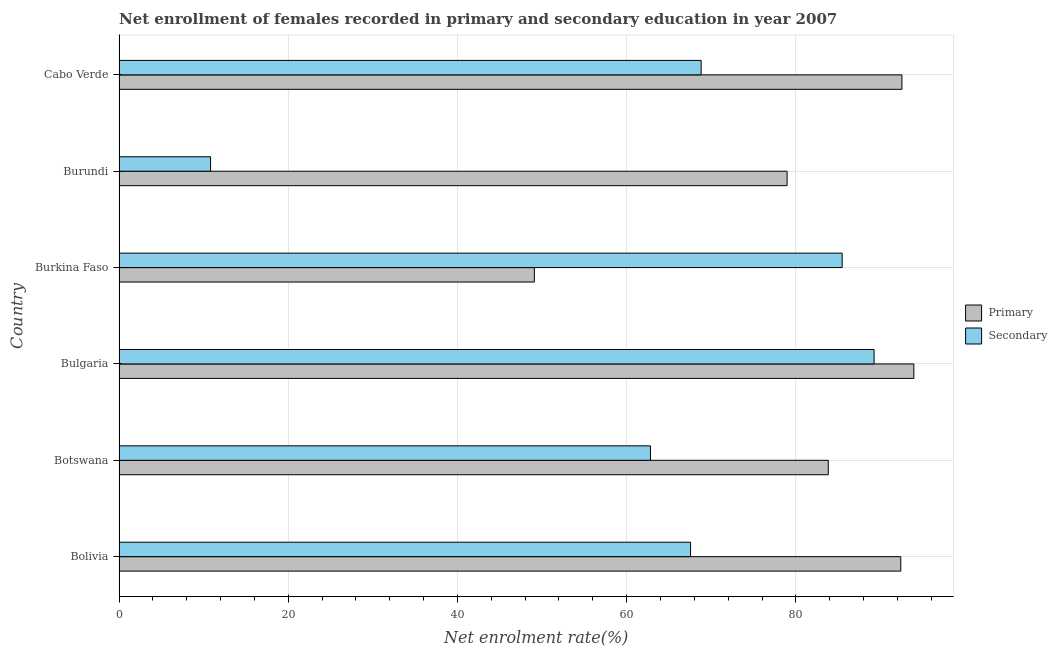How many groups of bars are there?
Your response must be concise. 6. Are the number of bars per tick equal to the number of legend labels?
Your answer should be very brief. Yes. Are the number of bars on each tick of the Y-axis equal?
Ensure brevity in your answer.  Yes. How many bars are there on the 4th tick from the top?
Your answer should be compact. 2. What is the label of the 3rd group of bars from the top?
Your response must be concise. Burkina Faso. In how many cases, is the number of bars for a given country not equal to the number of legend labels?
Your answer should be very brief. 0. What is the enrollment rate in primary education in Bolivia?
Provide a succinct answer. 92.4. Across all countries, what is the maximum enrollment rate in primary education?
Your answer should be very brief. 93.94. Across all countries, what is the minimum enrollment rate in secondary education?
Provide a short and direct response. 10.82. In which country was the enrollment rate in primary education maximum?
Make the answer very short. Bulgaria. In which country was the enrollment rate in primary education minimum?
Offer a terse response. Burkina Faso. What is the total enrollment rate in primary education in the graph?
Offer a terse response. 490.75. What is the difference between the enrollment rate in primary education in Burkina Faso and that in Burundi?
Offer a very short reply. -29.87. What is the difference between the enrollment rate in secondary education in Bulgaria and the enrollment rate in primary education in Burkina Faso?
Make the answer very short. 40.15. What is the average enrollment rate in primary education per country?
Your answer should be compact. 81.79. What is the difference between the enrollment rate in primary education and enrollment rate in secondary education in Bolivia?
Ensure brevity in your answer.  24.85. In how many countries, is the enrollment rate in primary education greater than 4 %?
Offer a very short reply. 6. What is the ratio of the enrollment rate in secondary education in Bolivia to that in Burkina Faso?
Keep it short and to the point. 0.79. Is the enrollment rate in primary education in Bolivia less than that in Bulgaria?
Ensure brevity in your answer.  Yes. What is the difference between the highest and the second highest enrollment rate in primary education?
Your answer should be compact. 1.41. What is the difference between the highest and the lowest enrollment rate in secondary education?
Keep it short and to the point. 78.42. In how many countries, is the enrollment rate in secondary education greater than the average enrollment rate in secondary education taken over all countries?
Your answer should be very brief. 4. Is the sum of the enrollment rate in secondary education in Bolivia and Botswana greater than the maximum enrollment rate in primary education across all countries?
Offer a terse response. Yes. What does the 1st bar from the top in Burkina Faso represents?
Offer a terse response. Secondary. What does the 1st bar from the bottom in Botswana represents?
Provide a succinct answer. Primary. How many bars are there?
Make the answer very short. 12. Are all the bars in the graph horizontal?
Ensure brevity in your answer.  Yes. Are the values on the major ticks of X-axis written in scientific E-notation?
Keep it short and to the point. No. Does the graph contain grids?
Your answer should be very brief. Yes. Where does the legend appear in the graph?
Give a very brief answer. Center right. What is the title of the graph?
Give a very brief answer. Net enrollment of females recorded in primary and secondary education in year 2007. What is the label or title of the X-axis?
Your response must be concise. Net enrolment rate(%). What is the label or title of the Y-axis?
Offer a very short reply. Country. What is the Net enrolment rate(%) in Primary in Bolivia?
Your answer should be very brief. 92.4. What is the Net enrolment rate(%) of Secondary in Bolivia?
Make the answer very short. 67.55. What is the Net enrolment rate(%) of Primary in Botswana?
Your response must be concise. 83.83. What is the Net enrolment rate(%) of Secondary in Botswana?
Provide a short and direct response. 62.81. What is the Net enrolment rate(%) of Primary in Bulgaria?
Offer a very short reply. 93.94. What is the Net enrolment rate(%) of Secondary in Bulgaria?
Provide a short and direct response. 89.24. What is the Net enrolment rate(%) of Primary in Burkina Faso?
Your answer should be compact. 49.09. What is the Net enrolment rate(%) of Secondary in Burkina Faso?
Give a very brief answer. 85.47. What is the Net enrolment rate(%) of Primary in Burundi?
Give a very brief answer. 78.96. What is the Net enrolment rate(%) in Secondary in Burundi?
Your response must be concise. 10.82. What is the Net enrolment rate(%) of Primary in Cabo Verde?
Provide a short and direct response. 92.53. What is the Net enrolment rate(%) of Secondary in Cabo Verde?
Your answer should be compact. 68.8. Across all countries, what is the maximum Net enrolment rate(%) in Primary?
Provide a succinct answer. 93.94. Across all countries, what is the maximum Net enrolment rate(%) in Secondary?
Provide a short and direct response. 89.24. Across all countries, what is the minimum Net enrolment rate(%) of Primary?
Keep it short and to the point. 49.09. Across all countries, what is the minimum Net enrolment rate(%) in Secondary?
Offer a very short reply. 10.82. What is the total Net enrolment rate(%) of Primary in the graph?
Your response must be concise. 490.75. What is the total Net enrolment rate(%) in Secondary in the graph?
Your answer should be compact. 384.7. What is the difference between the Net enrolment rate(%) of Primary in Bolivia and that in Botswana?
Offer a very short reply. 8.57. What is the difference between the Net enrolment rate(%) in Secondary in Bolivia and that in Botswana?
Provide a short and direct response. 4.74. What is the difference between the Net enrolment rate(%) in Primary in Bolivia and that in Bulgaria?
Give a very brief answer. -1.55. What is the difference between the Net enrolment rate(%) in Secondary in Bolivia and that in Bulgaria?
Give a very brief answer. -21.69. What is the difference between the Net enrolment rate(%) in Primary in Bolivia and that in Burkina Faso?
Offer a very short reply. 43.31. What is the difference between the Net enrolment rate(%) of Secondary in Bolivia and that in Burkina Faso?
Ensure brevity in your answer.  -17.92. What is the difference between the Net enrolment rate(%) in Primary in Bolivia and that in Burundi?
Offer a very short reply. 13.44. What is the difference between the Net enrolment rate(%) in Secondary in Bolivia and that in Burundi?
Your answer should be very brief. 56.73. What is the difference between the Net enrolment rate(%) of Primary in Bolivia and that in Cabo Verde?
Your answer should be compact. -0.14. What is the difference between the Net enrolment rate(%) in Secondary in Bolivia and that in Cabo Verde?
Make the answer very short. -1.25. What is the difference between the Net enrolment rate(%) in Primary in Botswana and that in Bulgaria?
Give a very brief answer. -10.11. What is the difference between the Net enrolment rate(%) in Secondary in Botswana and that in Bulgaria?
Make the answer very short. -26.43. What is the difference between the Net enrolment rate(%) of Primary in Botswana and that in Burkina Faso?
Ensure brevity in your answer.  34.74. What is the difference between the Net enrolment rate(%) in Secondary in Botswana and that in Burkina Faso?
Offer a terse response. -22.65. What is the difference between the Net enrolment rate(%) of Primary in Botswana and that in Burundi?
Provide a succinct answer. 4.87. What is the difference between the Net enrolment rate(%) of Secondary in Botswana and that in Burundi?
Offer a very short reply. 52. What is the difference between the Net enrolment rate(%) of Primary in Botswana and that in Cabo Verde?
Your answer should be very brief. -8.71. What is the difference between the Net enrolment rate(%) in Secondary in Botswana and that in Cabo Verde?
Offer a very short reply. -5.99. What is the difference between the Net enrolment rate(%) in Primary in Bulgaria and that in Burkina Faso?
Your answer should be very brief. 44.85. What is the difference between the Net enrolment rate(%) in Secondary in Bulgaria and that in Burkina Faso?
Your answer should be very brief. 3.77. What is the difference between the Net enrolment rate(%) of Primary in Bulgaria and that in Burundi?
Make the answer very short. 14.98. What is the difference between the Net enrolment rate(%) of Secondary in Bulgaria and that in Burundi?
Offer a terse response. 78.42. What is the difference between the Net enrolment rate(%) of Primary in Bulgaria and that in Cabo Verde?
Provide a short and direct response. 1.41. What is the difference between the Net enrolment rate(%) of Secondary in Bulgaria and that in Cabo Verde?
Ensure brevity in your answer.  20.44. What is the difference between the Net enrolment rate(%) in Primary in Burkina Faso and that in Burundi?
Keep it short and to the point. -29.87. What is the difference between the Net enrolment rate(%) of Secondary in Burkina Faso and that in Burundi?
Give a very brief answer. 74.65. What is the difference between the Net enrolment rate(%) of Primary in Burkina Faso and that in Cabo Verde?
Ensure brevity in your answer.  -43.45. What is the difference between the Net enrolment rate(%) in Secondary in Burkina Faso and that in Cabo Verde?
Provide a short and direct response. 16.67. What is the difference between the Net enrolment rate(%) in Primary in Burundi and that in Cabo Verde?
Make the answer very short. -13.57. What is the difference between the Net enrolment rate(%) in Secondary in Burundi and that in Cabo Verde?
Your response must be concise. -57.98. What is the difference between the Net enrolment rate(%) of Primary in Bolivia and the Net enrolment rate(%) of Secondary in Botswana?
Give a very brief answer. 29.58. What is the difference between the Net enrolment rate(%) of Primary in Bolivia and the Net enrolment rate(%) of Secondary in Bulgaria?
Your response must be concise. 3.15. What is the difference between the Net enrolment rate(%) of Primary in Bolivia and the Net enrolment rate(%) of Secondary in Burkina Faso?
Ensure brevity in your answer.  6.93. What is the difference between the Net enrolment rate(%) of Primary in Bolivia and the Net enrolment rate(%) of Secondary in Burundi?
Your answer should be compact. 81.58. What is the difference between the Net enrolment rate(%) of Primary in Bolivia and the Net enrolment rate(%) of Secondary in Cabo Verde?
Your response must be concise. 23.59. What is the difference between the Net enrolment rate(%) of Primary in Botswana and the Net enrolment rate(%) of Secondary in Bulgaria?
Your answer should be very brief. -5.41. What is the difference between the Net enrolment rate(%) in Primary in Botswana and the Net enrolment rate(%) in Secondary in Burkina Faso?
Offer a terse response. -1.64. What is the difference between the Net enrolment rate(%) of Primary in Botswana and the Net enrolment rate(%) of Secondary in Burundi?
Your response must be concise. 73.01. What is the difference between the Net enrolment rate(%) in Primary in Botswana and the Net enrolment rate(%) in Secondary in Cabo Verde?
Your answer should be very brief. 15.03. What is the difference between the Net enrolment rate(%) of Primary in Bulgaria and the Net enrolment rate(%) of Secondary in Burkina Faso?
Provide a short and direct response. 8.47. What is the difference between the Net enrolment rate(%) in Primary in Bulgaria and the Net enrolment rate(%) in Secondary in Burundi?
Your answer should be compact. 83.12. What is the difference between the Net enrolment rate(%) of Primary in Bulgaria and the Net enrolment rate(%) of Secondary in Cabo Verde?
Your answer should be compact. 25.14. What is the difference between the Net enrolment rate(%) of Primary in Burkina Faso and the Net enrolment rate(%) of Secondary in Burundi?
Provide a succinct answer. 38.27. What is the difference between the Net enrolment rate(%) in Primary in Burkina Faso and the Net enrolment rate(%) in Secondary in Cabo Verde?
Your answer should be compact. -19.71. What is the difference between the Net enrolment rate(%) in Primary in Burundi and the Net enrolment rate(%) in Secondary in Cabo Verde?
Your answer should be very brief. 10.16. What is the average Net enrolment rate(%) in Primary per country?
Ensure brevity in your answer.  81.79. What is the average Net enrolment rate(%) in Secondary per country?
Offer a very short reply. 64.12. What is the difference between the Net enrolment rate(%) in Primary and Net enrolment rate(%) in Secondary in Bolivia?
Offer a very short reply. 24.85. What is the difference between the Net enrolment rate(%) of Primary and Net enrolment rate(%) of Secondary in Botswana?
Offer a terse response. 21.01. What is the difference between the Net enrolment rate(%) of Primary and Net enrolment rate(%) of Secondary in Bulgaria?
Your answer should be very brief. 4.7. What is the difference between the Net enrolment rate(%) of Primary and Net enrolment rate(%) of Secondary in Burkina Faso?
Give a very brief answer. -36.38. What is the difference between the Net enrolment rate(%) in Primary and Net enrolment rate(%) in Secondary in Burundi?
Make the answer very short. 68.14. What is the difference between the Net enrolment rate(%) in Primary and Net enrolment rate(%) in Secondary in Cabo Verde?
Your response must be concise. 23.73. What is the ratio of the Net enrolment rate(%) in Primary in Bolivia to that in Botswana?
Your answer should be compact. 1.1. What is the ratio of the Net enrolment rate(%) of Secondary in Bolivia to that in Botswana?
Offer a very short reply. 1.08. What is the ratio of the Net enrolment rate(%) in Primary in Bolivia to that in Bulgaria?
Your answer should be compact. 0.98. What is the ratio of the Net enrolment rate(%) in Secondary in Bolivia to that in Bulgaria?
Give a very brief answer. 0.76. What is the ratio of the Net enrolment rate(%) of Primary in Bolivia to that in Burkina Faso?
Offer a very short reply. 1.88. What is the ratio of the Net enrolment rate(%) of Secondary in Bolivia to that in Burkina Faso?
Offer a very short reply. 0.79. What is the ratio of the Net enrolment rate(%) of Primary in Bolivia to that in Burundi?
Provide a succinct answer. 1.17. What is the ratio of the Net enrolment rate(%) in Secondary in Bolivia to that in Burundi?
Your answer should be compact. 6.24. What is the ratio of the Net enrolment rate(%) in Primary in Bolivia to that in Cabo Verde?
Offer a terse response. 1. What is the ratio of the Net enrolment rate(%) of Secondary in Bolivia to that in Cabo Verde?
Keep it short and to the point. 0.98. What is the ratio of the Net enrolment rate(%) of Primary in Botswana to that in Bulgaria?
Ensure brevity in your answer.  0.89. What is the ratio of the Net enrolment rate(%) of Secondary in Botswana to that in Bulgaria?
Your answer should be compact. 0.7. What is the ratio of the Net enrolment rate(%) in Primary in Botswana to that in Burkina Faso?
Ensure brevity in your answer.  1.71. What is the ratio of the Net enrolment rate(%) in Secondary in Botswana to that in Burkina Faso?
Offer a very short reply. 0.73. What is the ratio of the Net enrolment rate(%) of Primary in Botswana to that in Burundi?
Make the answer very short. 1.06. What is the ratio of the Net enrolment rate(%) in Secondary in Botswana to that in Burundi?
Provide a succinct answer. 5.81. What is the ratio of the Net enrolment rate(%) in Primary in Botswana to that in Cabo Verde?
Offer a very short reply. 0.91. What is the ratio of the Net enrolment rate(%) of Primary in Bulgaria to that in Burkina Faso?
Provide a short and direct response. 1.91. What is the ratio of the Net enrolment rate(%) in Secondary in Bulgaria to that in Burkina Faso?
Your answer should be compact. 1.04. What is the ratio of the Net enrolment rate(%) in Primary in Bulgaria to that in Burundi?
Make the answer very short. 1.19. What is the ratio of the Net enrolment rate(%) in Secondary in Bulgaria to that in Burundi?
Make the answer very short. 8.25. What is the ratio of the Net enrolment rate(%) of Primary in Bulgaria to that in Cabo Verde?
Your answer should be very brief. 1.02. What is the ratio of the Net enrolment rate(%) of Secondary in Bulgaria to that in Cabo Verde?
Ensure brevity in your answer.  1.3. What is the ratio of the Net enrolment rate(%) in Primary in Burkina Faso to that in Burundi?
Make the answer very short. 0.62. What is the ratio of the Net enrolment rate(%) of Secondary in Burkina Faso to that in Burundi?
Provide a succinct answer. 7.9. What is the ratio of the Net enrolment rate(%) in Primary in Burkina Faso to that in Cabo Verde?
Your answer should be compact. 0.53. What is the ratio of the Net enrolment rate(%) of Secondary in Burkina Faso to that in Cabo Verde?
Keep it short and to the point. 1.24. What is the ratio of the Net enrolment rate(%) in Primary in Burundi to that in Cabo Verde?
Your response must be concise. 0.85. What is the ratio of the Net enrolment rate(%) in Secondary in Burundi to that in Cabo Verde?
Offer a very short reply. 0.16. What is the difference between the highest and the second highest Net enrolment rate(%) of Primary?
Offer a very short reply. 1.41. What is the difference between the highest and the second highest Net enrolment rate(%) in Secondary?
Offer a terse response. 3.77. What is the difference between the highest and the lowest Net enrolment rate(%) of Primary?
Give a very brief answer. 44.85. What is the difference between the highest and the lowest Net enrolment rate(%) of Secondary?
Your answer should be very brief. 78.42. 